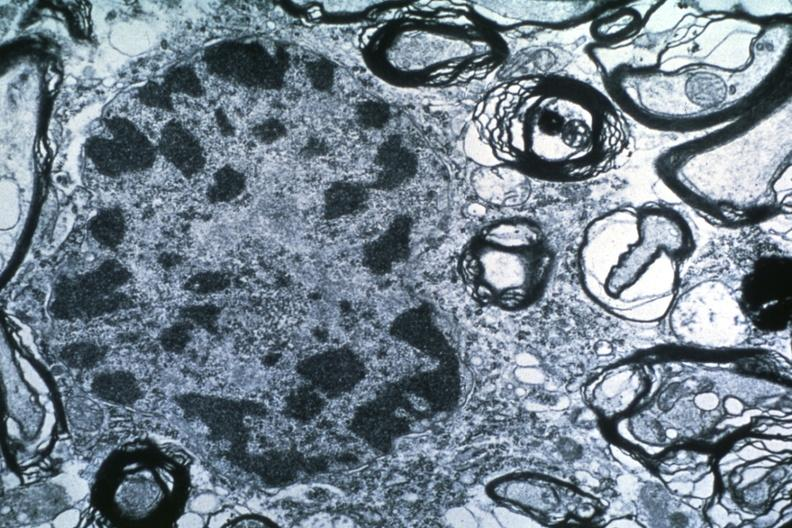s opened uterus and cervix with large cervical myoma protruding into vagina slide present?
Answer the question using a single word or phrase. No 